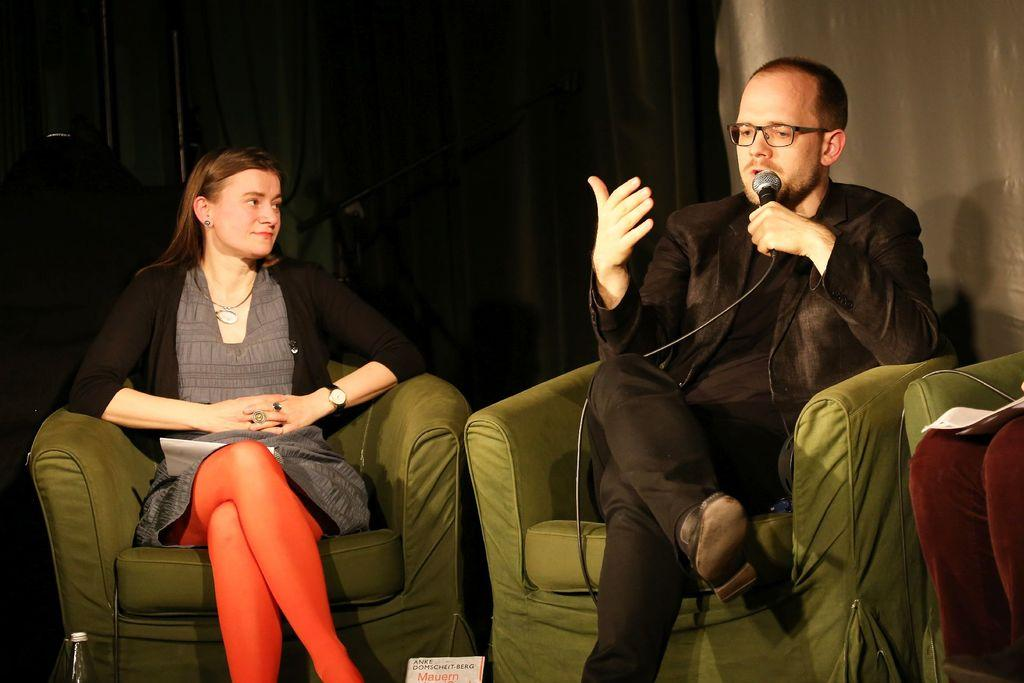What is the woman doing in the image? The beautiful woman is sitting on the sofa. Who else is sitting on the sofa? There is a man sitting on the sofa. What is the man doing in the image? The man is talking into a microphone. What is the man wearing in the image? The man is wearing a black dress. What type of feast is being prepared in the image? There is no mention of a feast or any food preparation in the image. 